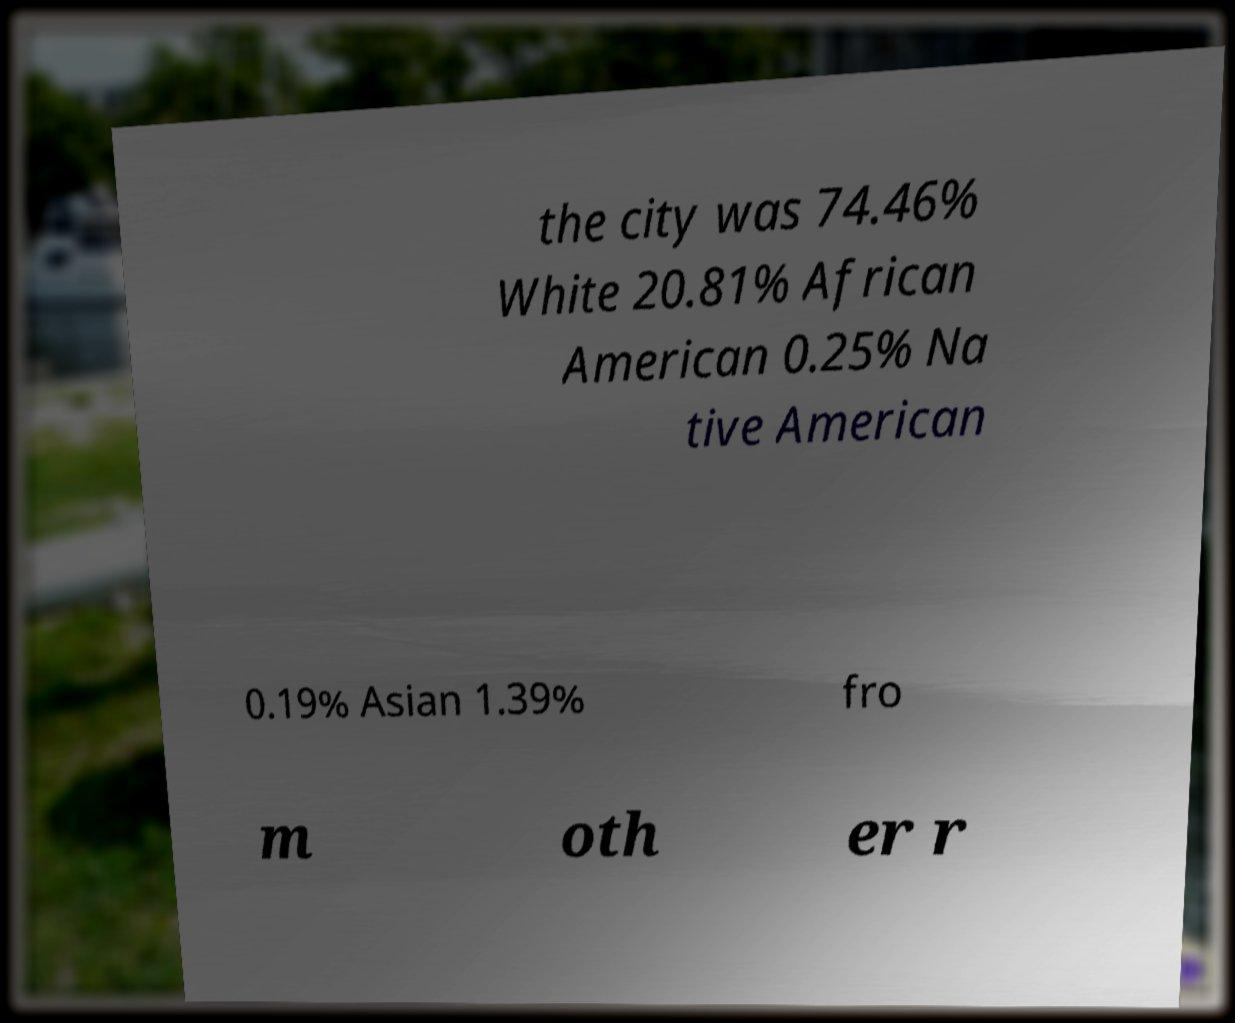Please read and relay the text visible in this image. What does it say? the city was 74.46% White 20.81% African American 0.25% Na tive American 0.19% Asian 1.39% fro m oth er r 